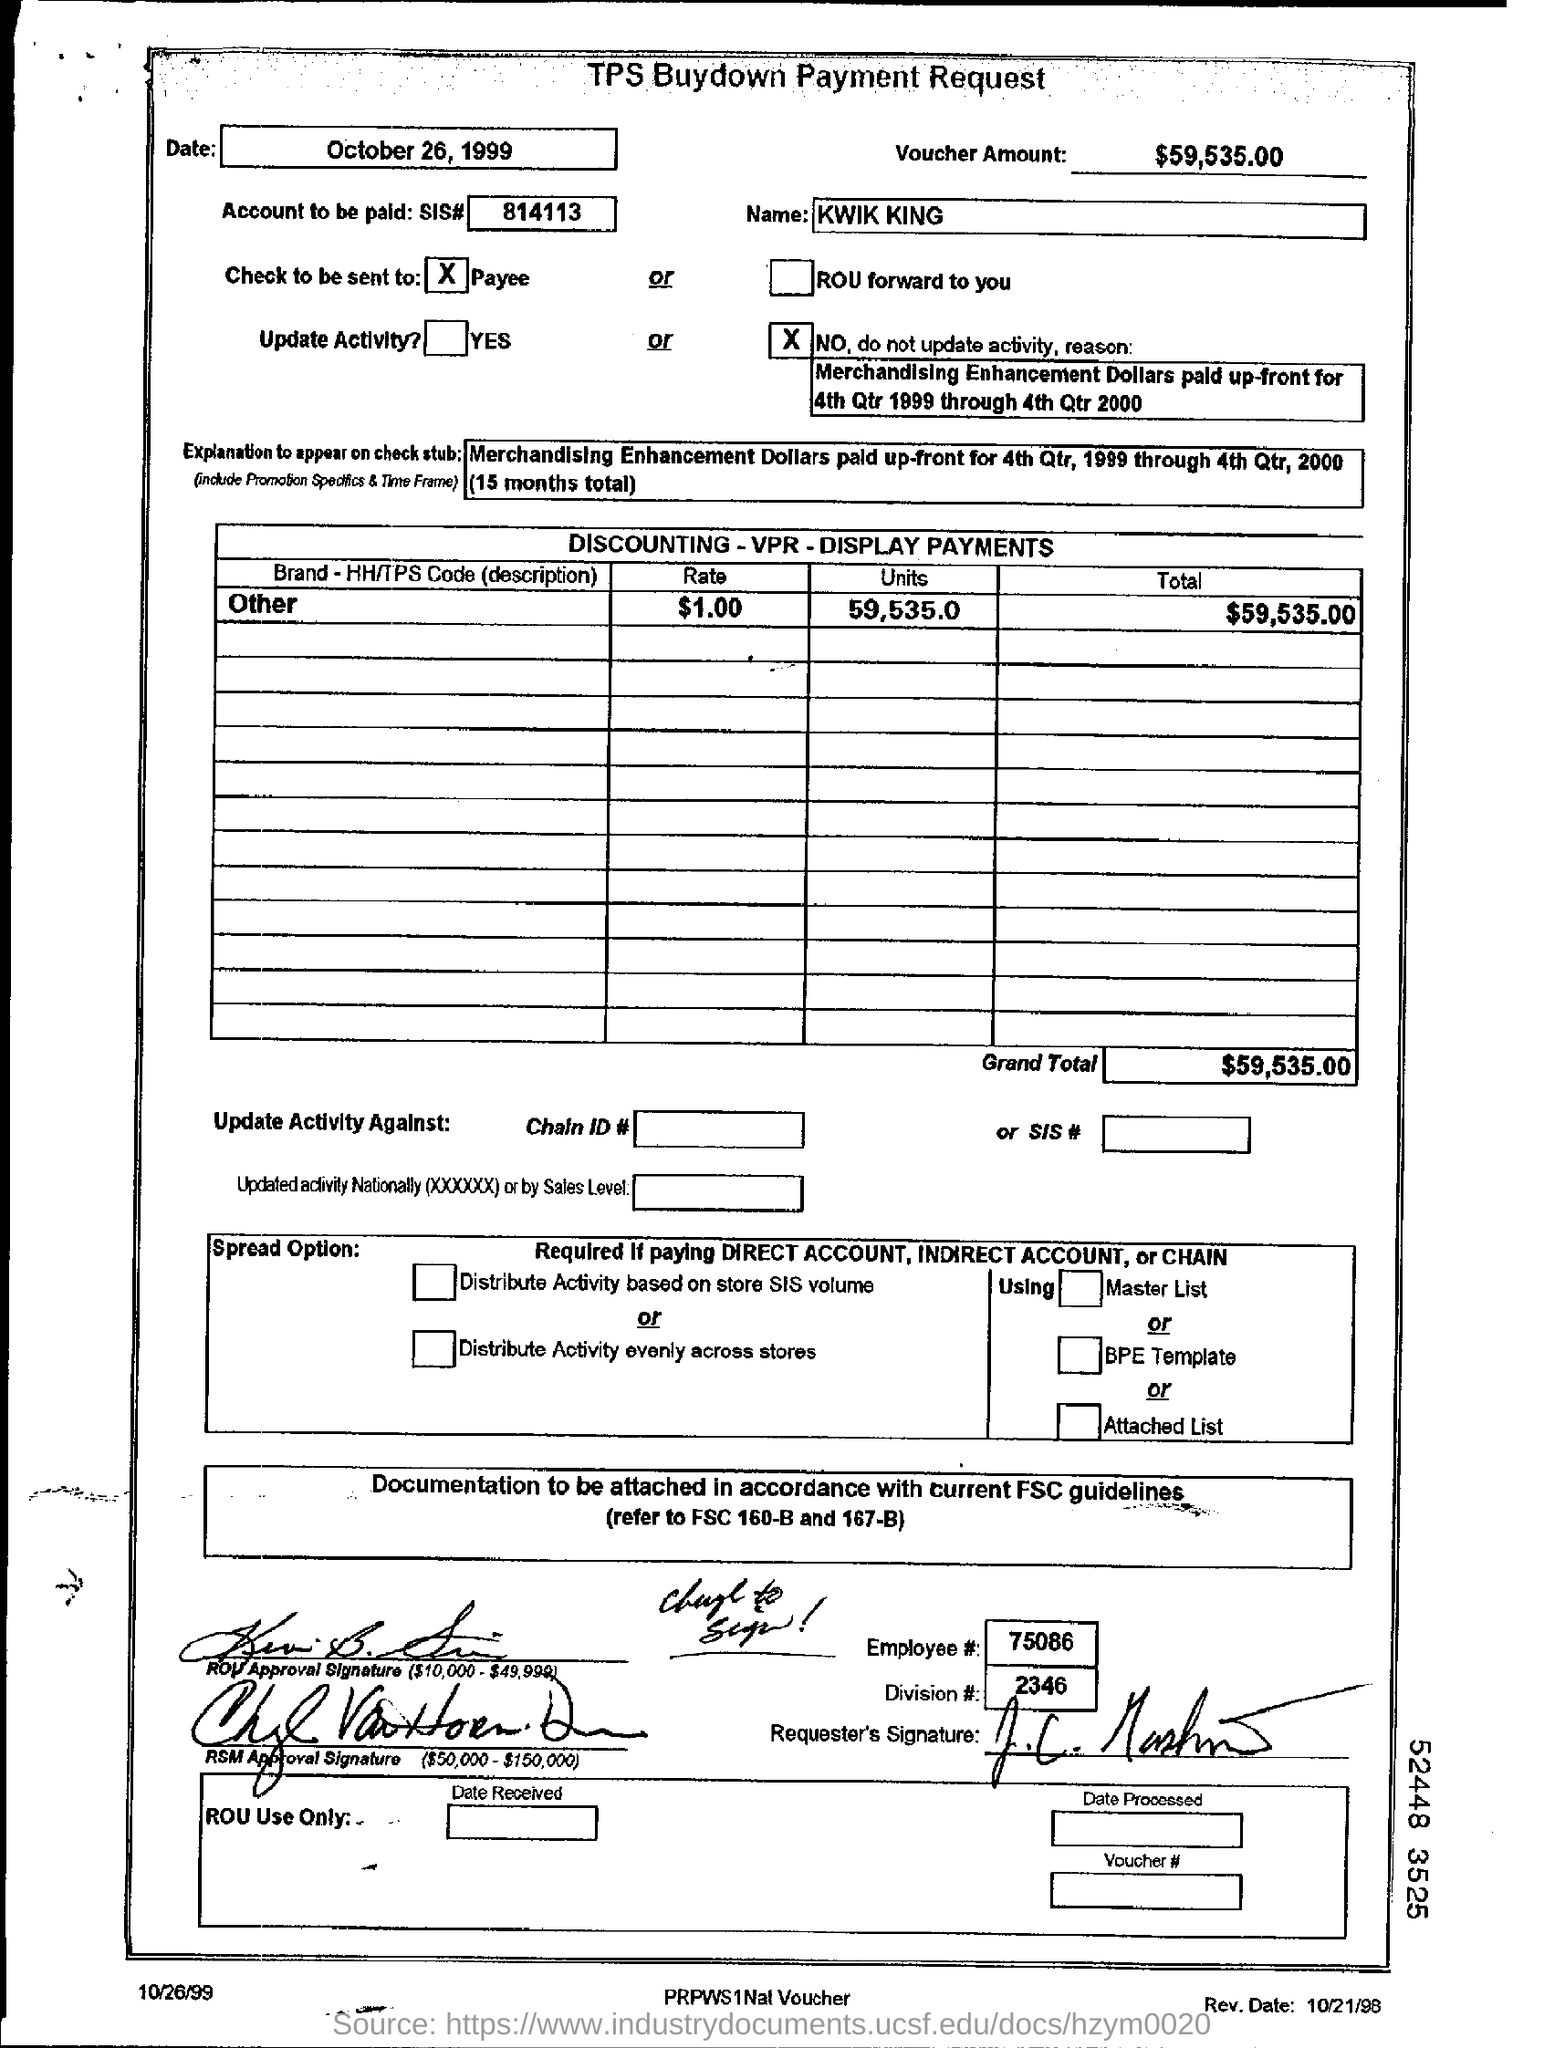Can you explain what the main purpose of this document is? The document appears to be a payment request form for a TPS Buydown, specifically regarding merchandising enhancement dollars allocated for a specific period. It outlines payment details to a payee named 'KWIK KING', including the amount, date, and related financial information. 